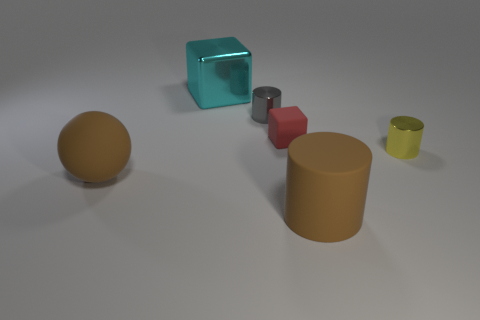Add 4 yellow objects. How many objects exist? 10 Subtract all spheres. How many objects are left? 5 Subtract all yellow cylinders. Subtract all small gray objects. How many objects are left? 4 Add 4 brown spheres. How many brown spheres are left? 5 Add 6 tiny purple metal blocks. How many tiny purple metal blocks exist? 6 Subtract 0 brown blocks. How many objects are left? 6 